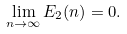Convert formula to latex. <formula><loc_0><loc_0><loc_500><loc_500>\lim _ { n \rightarrow \infty } E _ { 2 } ( n ) = 0 .</formula> 